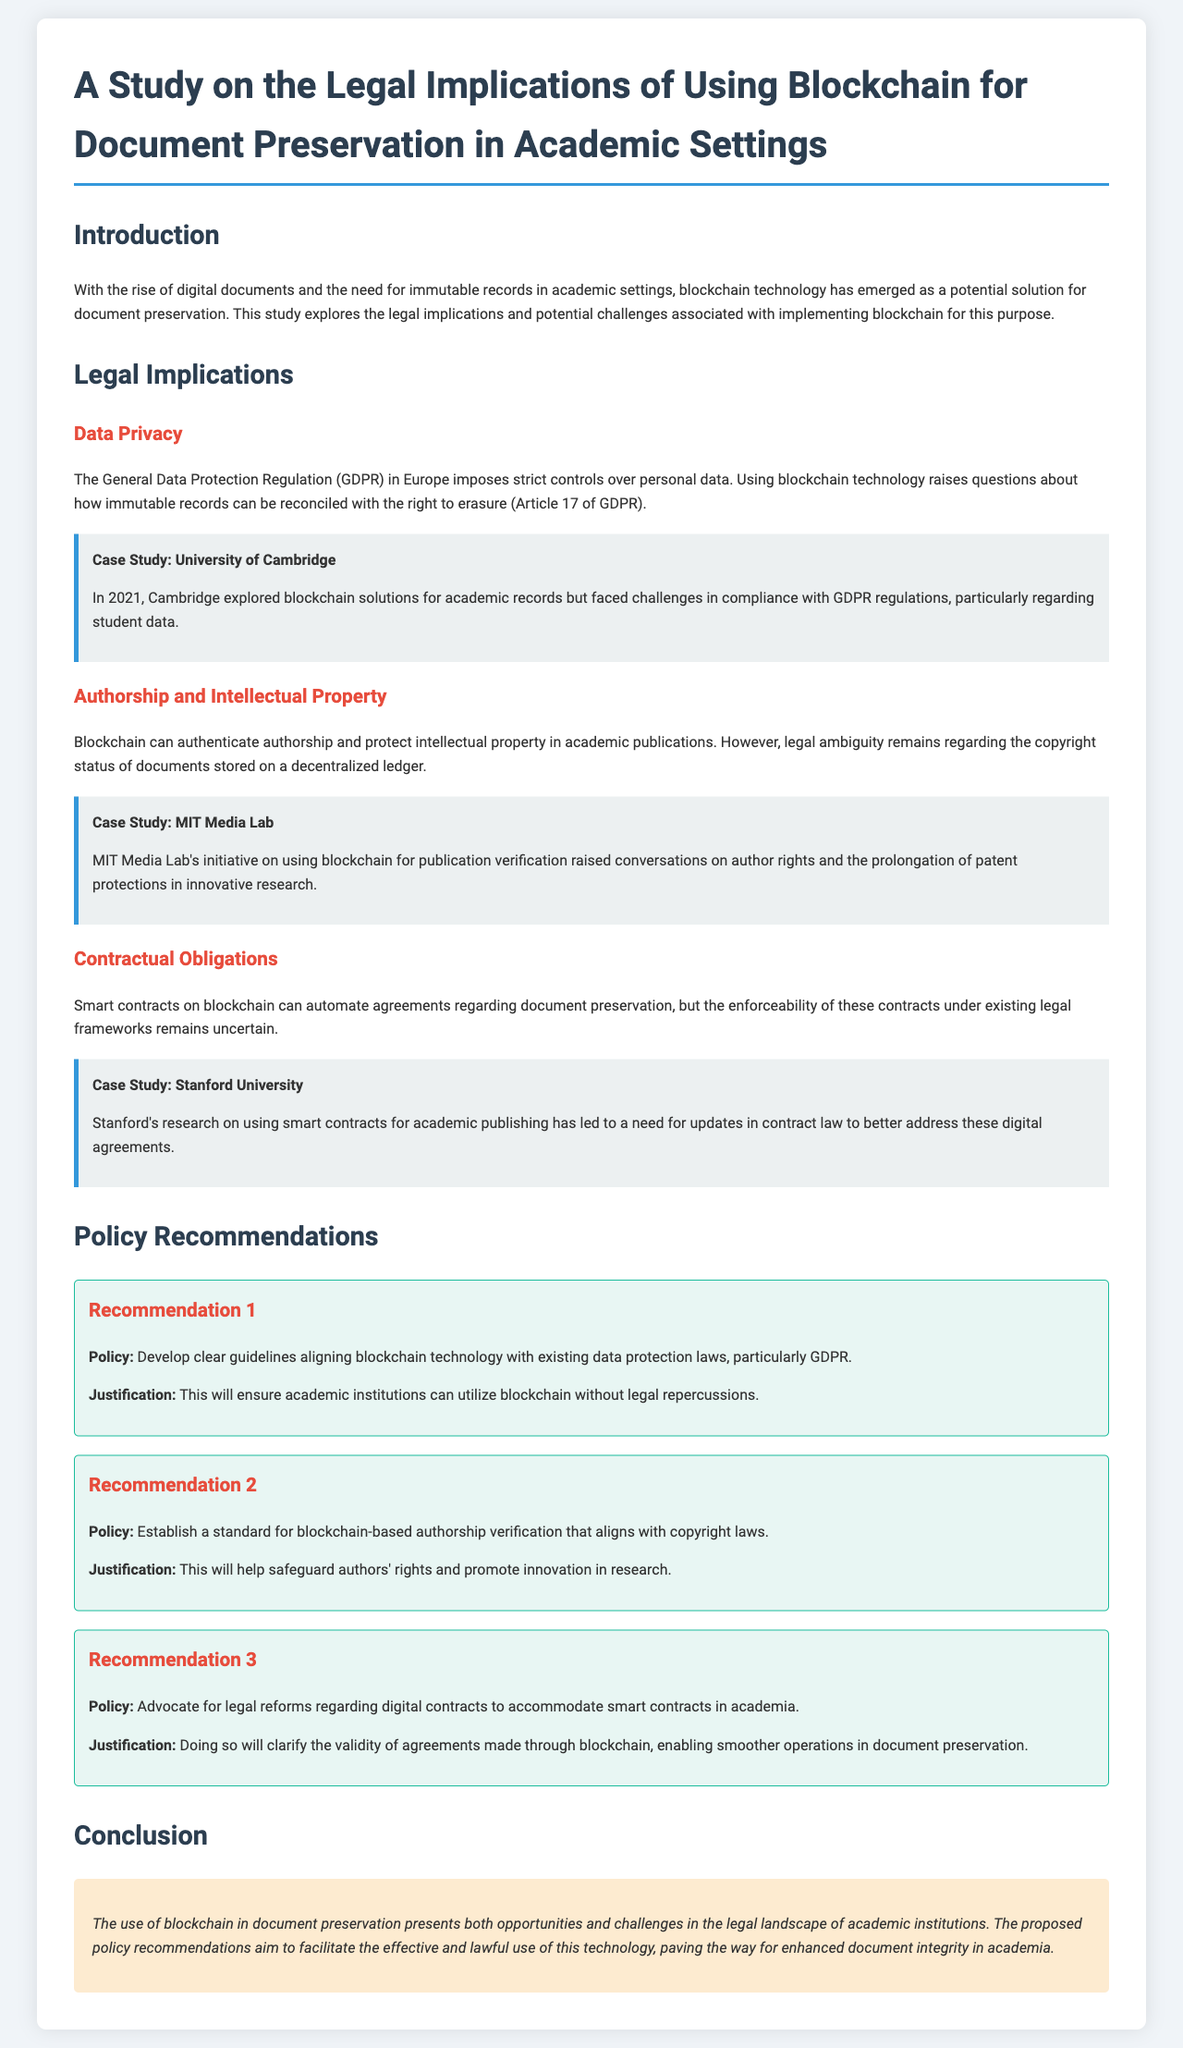What is the title of the study? The title of the study is indicated at the top of the document.
Answer: A Study on the Legal Implications of Using Blockchain for Document Preservation in Academic Settings What regulation poses challenges related to data privacy? The document mentions a specific regulation that sets strict controls on personal data.
Answer: GDPR Which university conducted a case study on blockchain solutions for academic records? The document provides a case study of a specific university's exploration of blockchain solutions.
Answer: University of Cambridge What is the first recommendation for policy development? The content lists a policy recommendation to develop guidelines for blockchain alignment with laws.
Answer: Develop clear guidelines aligning blockchain technology with existing data protection laws Which case study discusses the need for updates in contract law? The case study within the document mentions a specific university's research related to smart contracts and law updates.
Answer: Stanford University How many policy recommendations are listed in the document? The document presents a total number of recommendations pertaining to policy development.
Answer: Three What aspect of authorship is addressed in the recommendations? The document outlines standards for a specific aspect of authorship verification.
Answer: Authorship verification What issue does the use of blockchain raise concerning the right to erasure? The document explains a specific legal issue related to the right to erasure under GDPR when using blockchain technology.
Answer: Immutable records What is a potential benefit of using blockchain for academic document preservation? The document indicates a specific benefit of utilizing blockchain technology in academic settings.
Answer: Enhanced document integrity 